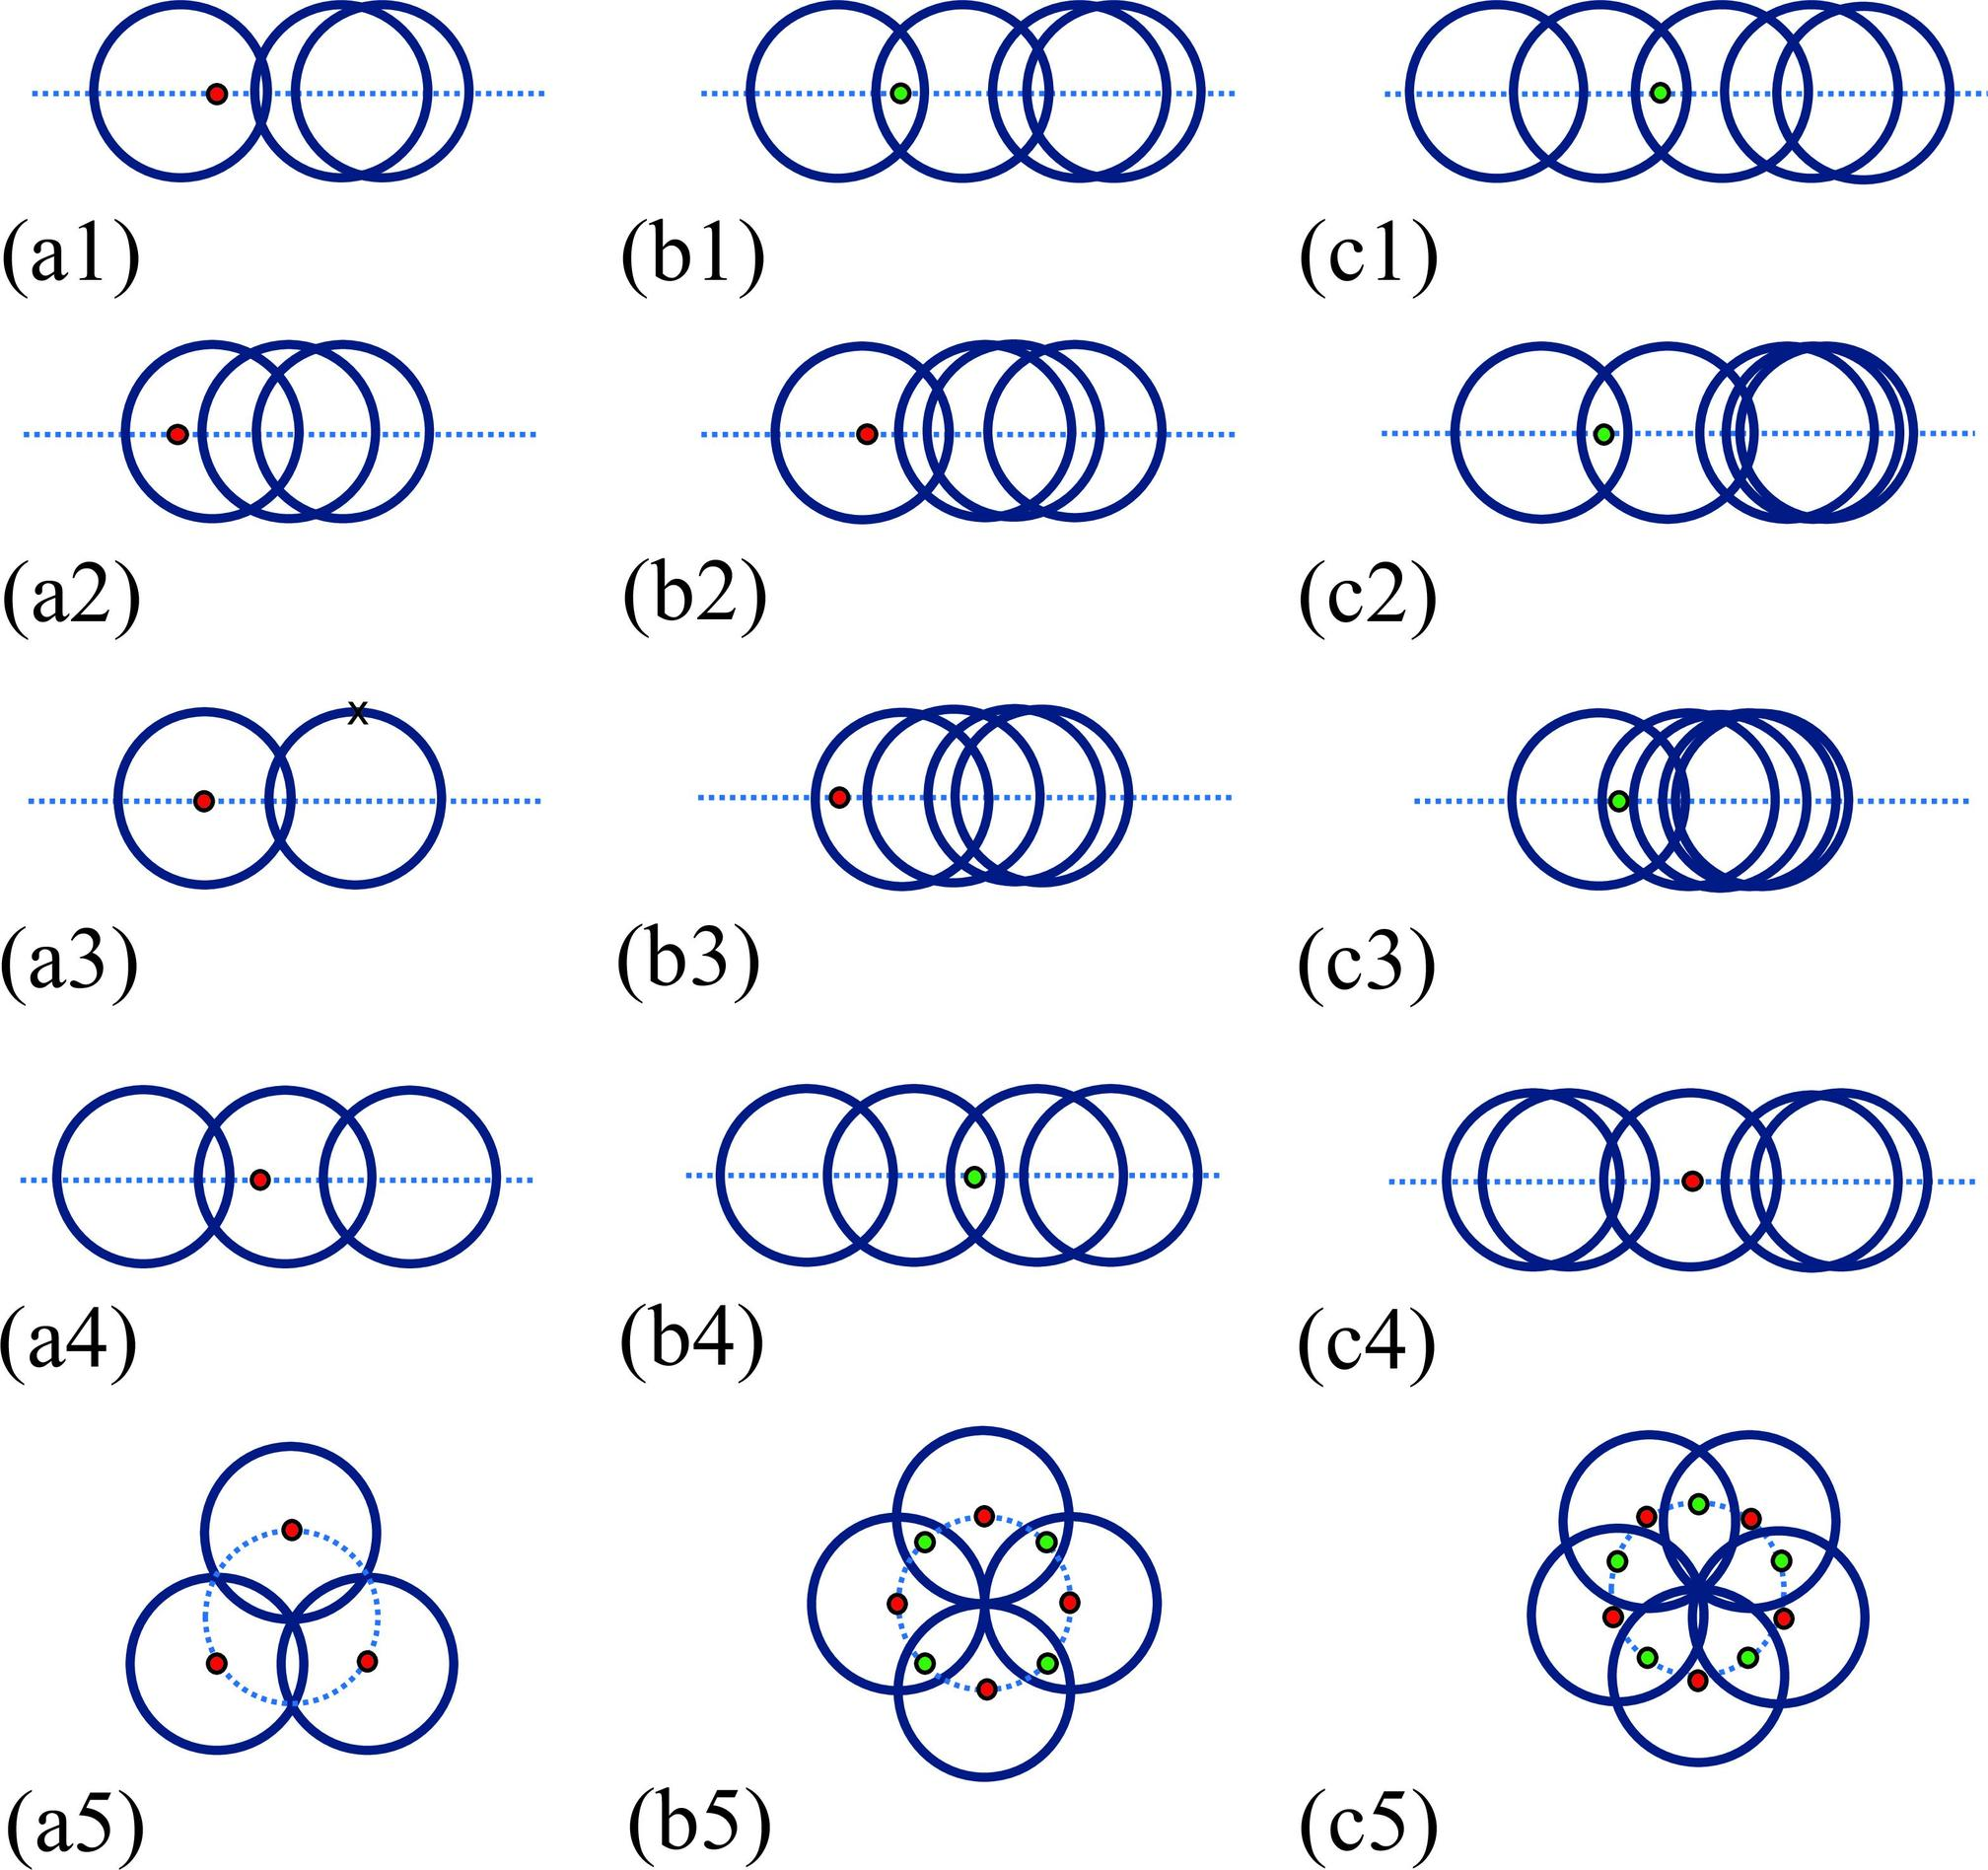How do figures b1 to b5 compare to figures c1 to c5 in terms of the interaction between the blue circles and the dots? Figures b1 to b5 and c1 to c5 showcase distinct interaction patterns between the blue circles and the dots. In series b, the blue circles mainly stay fixed while the configuration of the red dot changes slightly, indicating a static but responsive control mechanism. Conversely, in series c, there's a more evident dynamic interaction, with the green dot appearing to influence the arrangement of the blue circles, suggesting a more active and possibly bi-directional feedback mechanism between the dots and circles. 